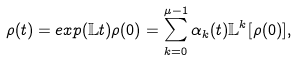Convert formula to latex. <formula><loc_0><loc_0><loc_500><loc_500>\rho ( t ) = e x p ( \mathbb { L } t ) \rho ( 0 ) = \sum _ { k = 0 } ^ { \mu - 1 } \alpha _ { k } ( t ) \mathbb { L } ^ { k } [ \rho ( 0 ) ] ,</formula> 